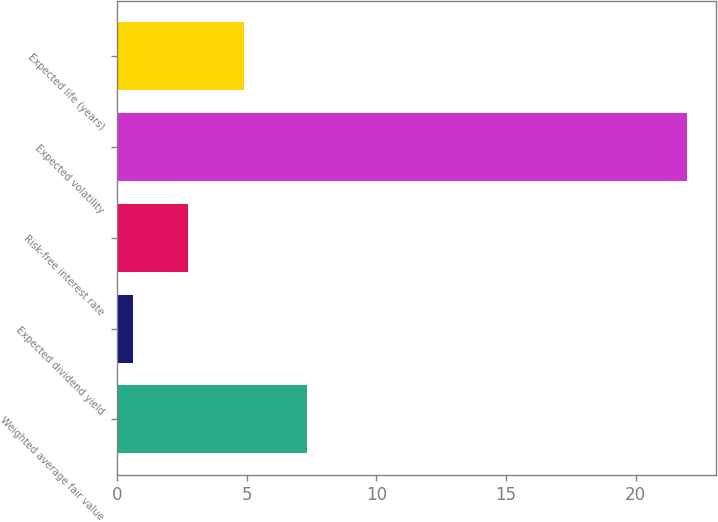Convert chart to OTSL. <chart><loc_0><loc_0><loc_500><loc_500><bar_chart><fcel>Weighted average fair value<fcel>Expected dividend yield<fcel>Risk-free interest rate<fcel>Expected volatility<fcel>Expected life (years)<nl><fcel>7.31<fcel>0.6<fcel>2.74<fcel>22<fcel>4.88<nl></chart> 